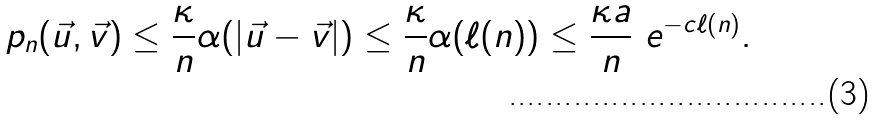Convert formula to latex. <formula><loc_0><loc_0><loc_500><loc_500>p _ { n } ( \vec { u } , \vec { v } ) \leq \frac { \kappa } { n } \alpha ( | \vec { u } - \vec { v } | ) \leq \frac { \kappa } { n } \alpha ( \ell ( n ) ) \leq \frac { \kappa a } { n } \ e ^ { - c \ell ( n ) } .</formula> 